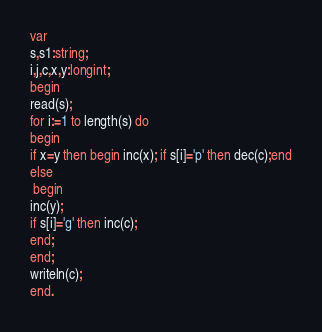Convert code to text. <code><loc_0><loc_0><loc_500><loc_500><_Pascal_>var
s,s1:string;
i,j,c,x,y:longint;
begin
read(s);
for i:=1 to length(s) do
begin
if x=y then begin inc(x); if s[i]='p' then dec(c);end
else
 begin
inc(y);
if s[i]='g' then inc(c);
end;
end;
writeln(c);
end.
</code> 